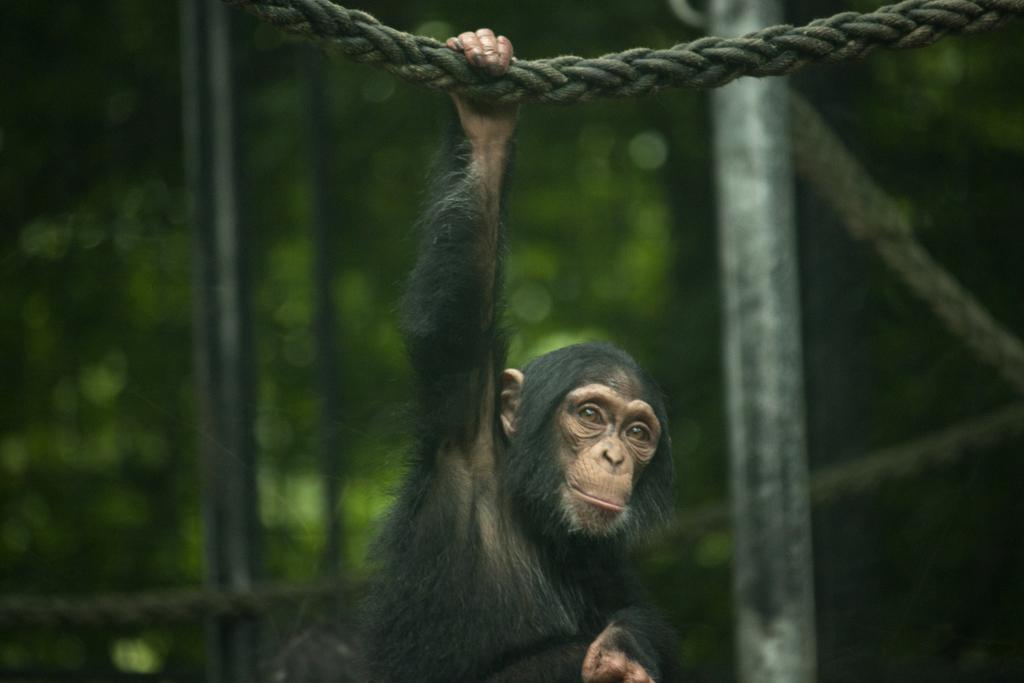What animal is present in the image? There is a monkey in the image. What is the monkey doing in the image? The monkey is hanging from a rope. What type of sink is visible in the image? There is no sink present in the image; it features a monkey hanging from a rope. What position is the bike in the image? There is no bike present in the image. 